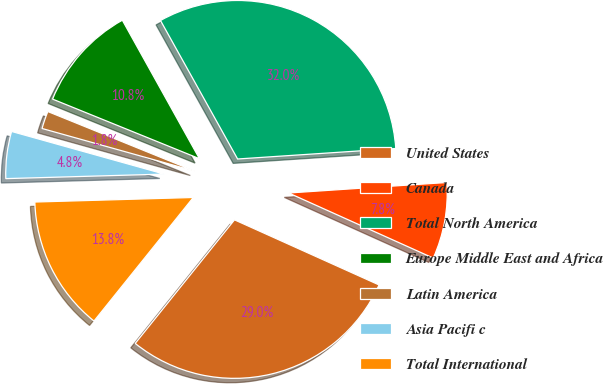<chart> <loc_0><loc_0><loc_500><loc_500><pie_chart><fcel>United States<fcel>Canada<fcel>Total North America<fcel>Europe Middle East and Africa<fcel>Latin America<fcel>Asia Pacifi c<fcel>Total International<nl><fcel>29.04%<fcel>7.79%<fcel>32.03%<fcel>10.78%<fcel>1.8%<fcel>4.79%<fcel>13.77%<nl></chart> 